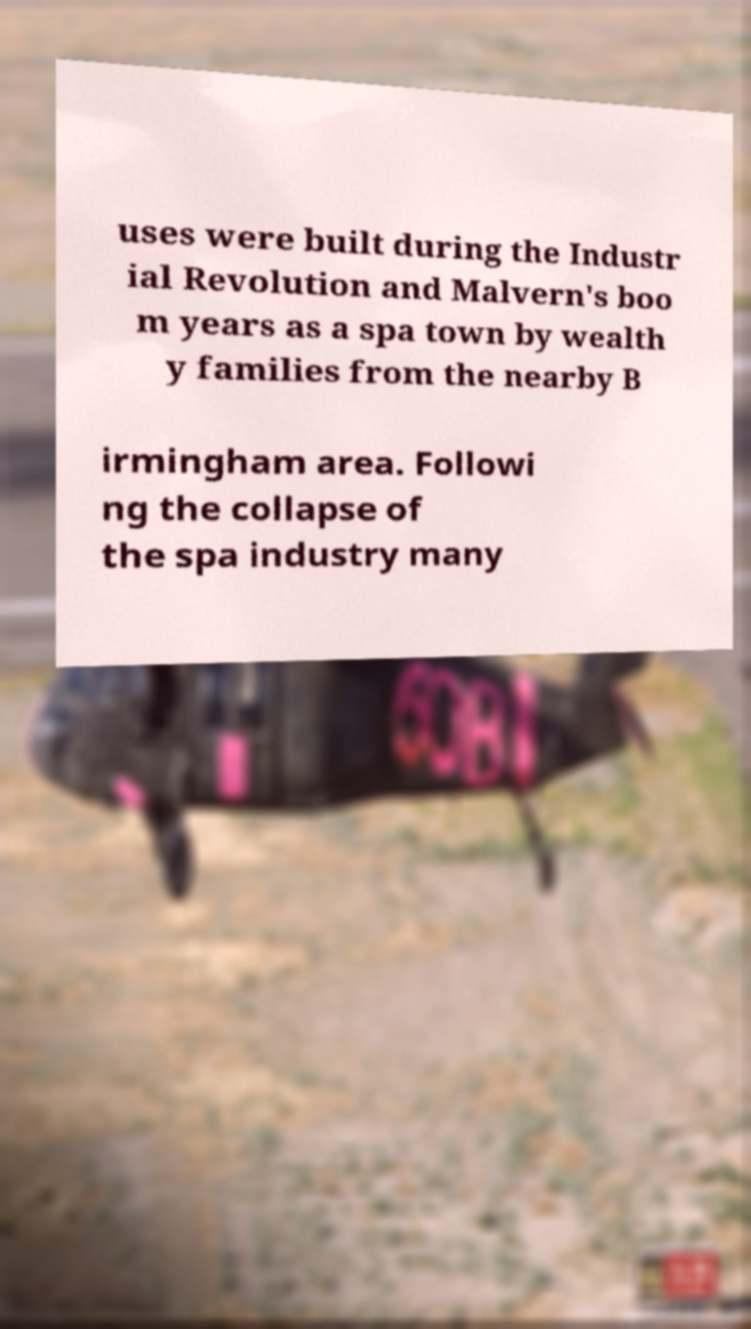Please identify and transcribe the text found in this image. uses were built during the Industr ial Revolution and Malvern's boo m years as a spa town by wealth y families from the nearby B irmingham area. Followi ng the collapse of the spa industry many 